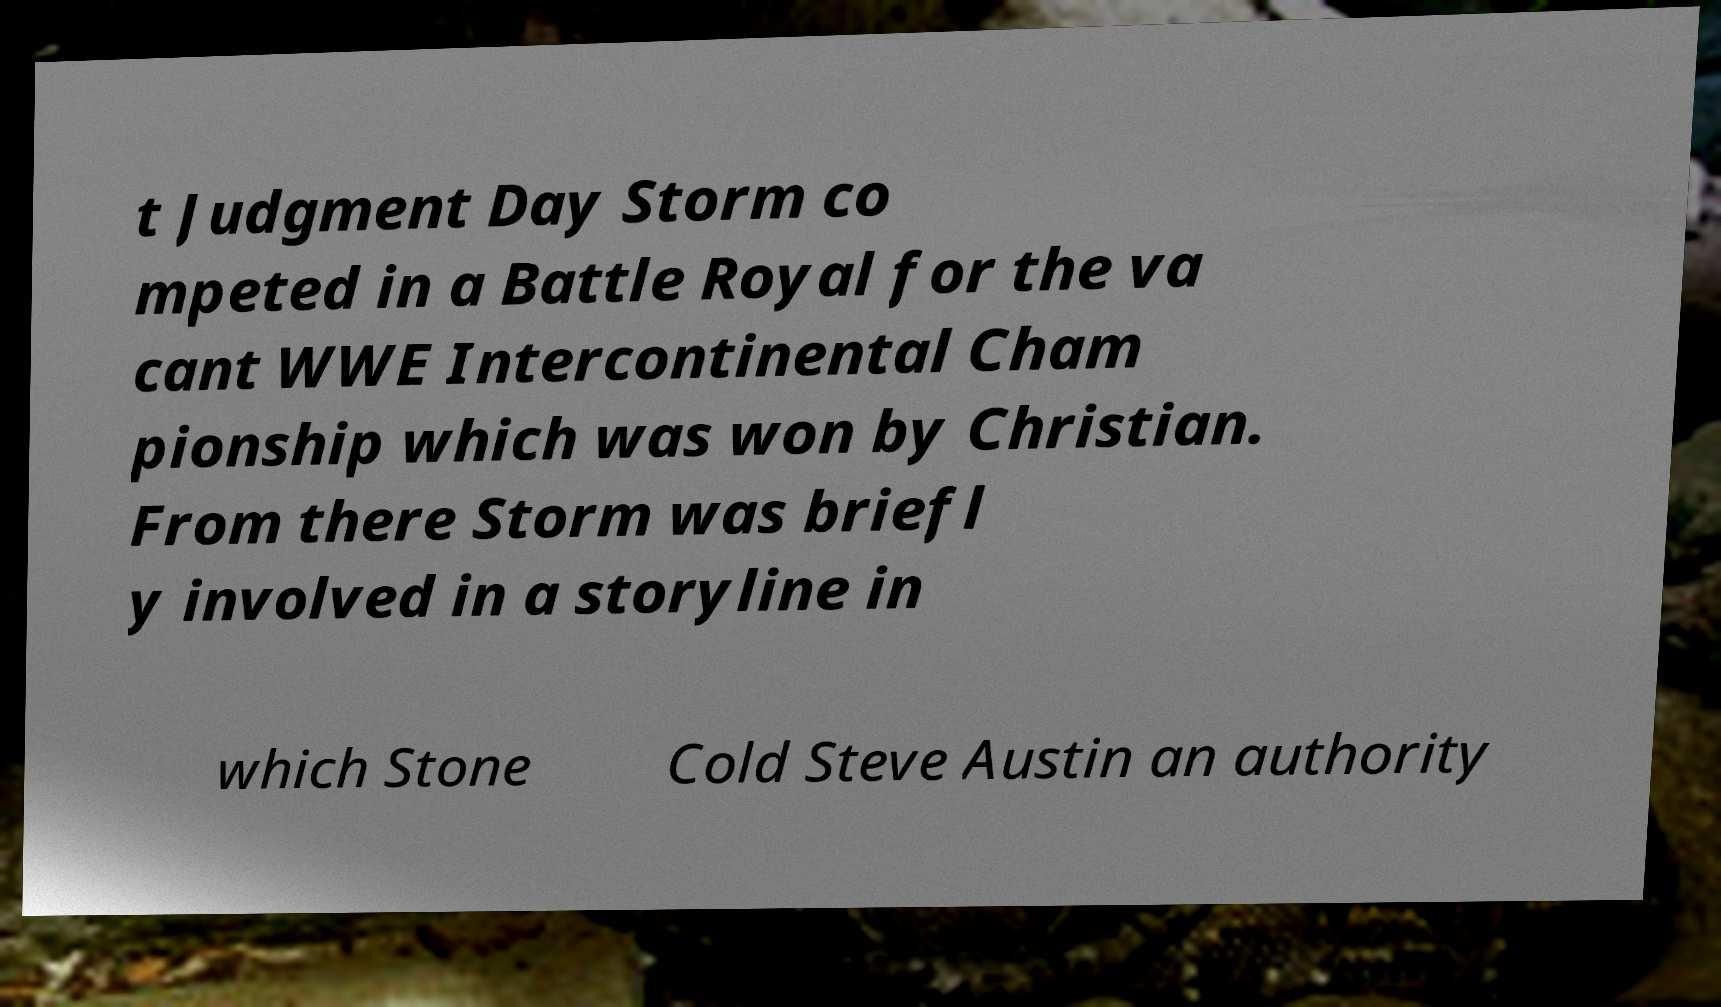There's text embedded in this image that I need extracted. Can you transcribe it verbatim? t Judgment Day Storm co mpeted in a Battle Royal for the va cant WWE Intercontinental Cham pionship which was won by Christian. From there Storm was briefl y involved in a storyline in which Stone Cold Steve Austin an authority 